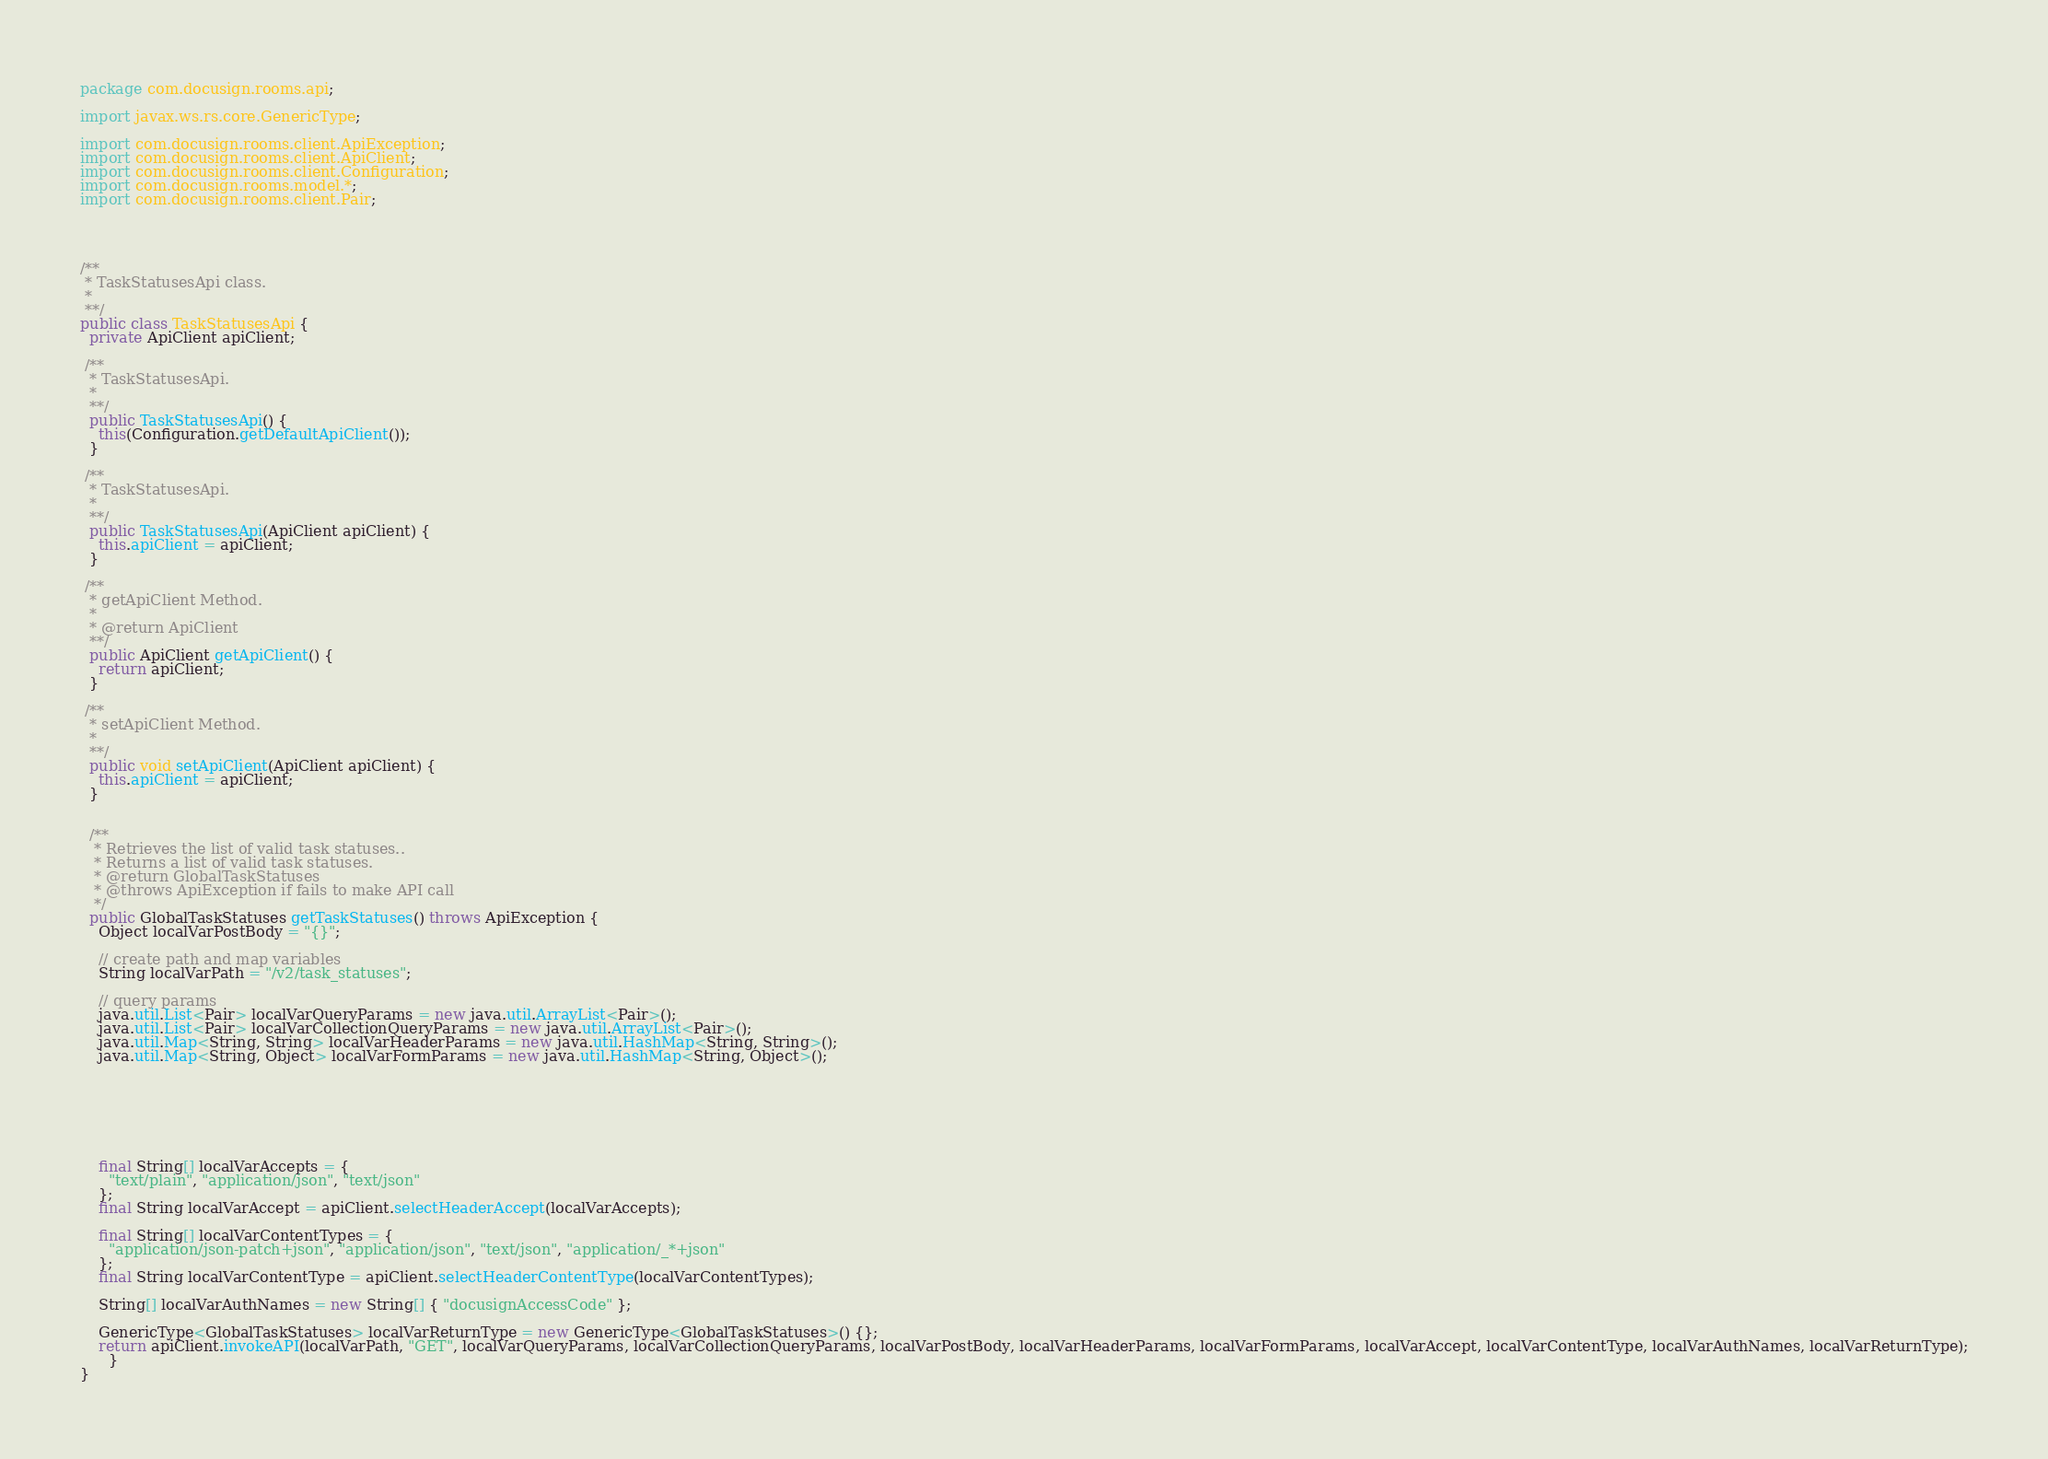Convert code to text. <code><loc_0><loc_0><loc_500><loc_500><_Java_>
package com.docusign.rooms.api;

import javax.ws.rs.core.GenericType;

import com.docusign.rooms.client.ApiException;
import com.docusign.rooms.client.ApiClient;
import com.docusign.rooms.client.Configuration;
import com.docusign.rooms.model.*;
import com.docusign.rooms.client.Pair;




/**
 * TaskStatusesApi class.
 *
 **/
public class TaskStatusesApi {
  private ApiClient apiClient;

 /**
  * TaskStatusesApi.
  *
  **/
  public TaskStatusesApi() {
    this(Configuration.getDefaultApiClient());
  }

 /**
  * TaskStatusesApi.
  *
  **/
  public TaskStatusesApi(ApiClient apiClient) {
    this.apiClient = apiClient;
  }

 /**
  * getApiClient Method.
  *
  * @return ApiClient
  **/
  public ApiClient getApiClient() {
    return apiClient;
  }

 /**
  * setApiClient Method.
  *
  **/
  public void setApiClient(ApiClient apiClient) {
    this.apiClient = apiClient;
  }


  /**
   * Retrieves the list of valid task statuses..
   * Returns a list of valid task statuses.
   * @return GlobalTaskStatuses
   * @throws ApiException if fails to make API call
   */
  public GlobalTaskStatuses getTaskStatuses() throws ApiException {
    Object localVarPostBody = "{}";
    
    // create path and map variables
    String localVarPath = "/v2/task_statuses";

    // query params
    java.util.List<Pair> localVarQueryParams = new java.util.ArrayList<Pair>();
    java.util.List<Pair> localVarCollectionQueryParams = new java.util.ArrayList<Pair>();
    java.util.Map<String, String> localVarHeaderParams = new java.util.HashMap<String, String>();
    java.util.Map<String, Object> localVarFormParams = new java.util.HashMap<String, Object>();

    

    

    

    final String[] localVarAccepts = {
      "text/plain", "application/json", "text/json"
    };
    final String localVarAccept = apiClient.selectHeaderAccept(localVarAccepts);

    final String[] localVarContentTypes = {
      "application/json-patch+json", "application/json", "text/json", "application/_*+json"
    };
    final String localVarContentType = apiClient.selectHeaderContentType(localVarContentTypes);

    String[] localVarAuthNames = new String[] { "docusignAccessCode" };

    GenericType<GlobalTaskStatuses> localVarReturnType = new GenericType<GlobalTaskStatuses>() {};
    return apiClient.invokeAPI(localVarPath, "GET", localVarQueryParams, localVarCollectionQueryParams, localVarPostBody, localVarHeaderParams, localVarFormParams, localVarAccept, localVarContentType, localVarAuthNames, localVarReturnType);
      }
}
</code> 